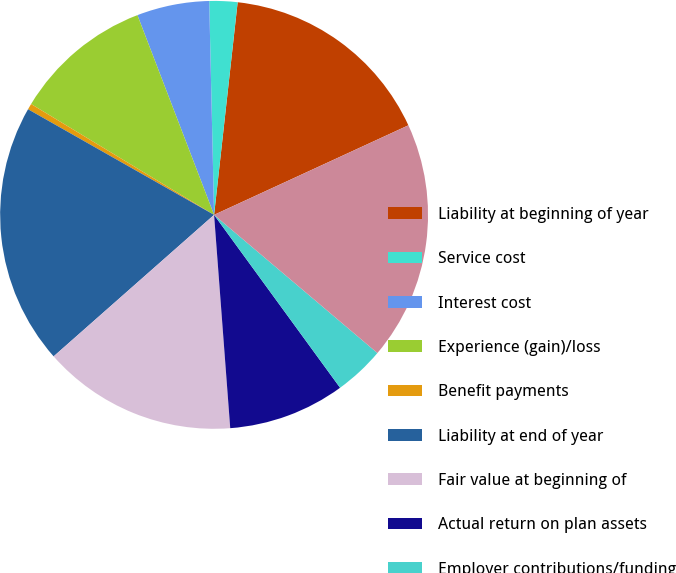<chart> <loc_0><loc_0><loc_500><loc_500><pie_chart><fcel>Liability at beginning of year<fcel>Service cost<fcel>Interest cost<fcel>Experience (gain)/loss<fcel>Benefit payments<fcel>Liability at end of year<fcel>Fair value at beginning of<fcel>Actual return on plan assets<fcel>Employer contributions/funding<fcel>Fair value at end of year<nl><fcel>16.37%<fcel>2.12%<fcel>5.47%<fcel>10.5%<fcel>0.45%<fcel>19.72%<fcel>14.7%<fcel>8.82%<fcel>3.8%<fcel>18.05%<nl></chart> 